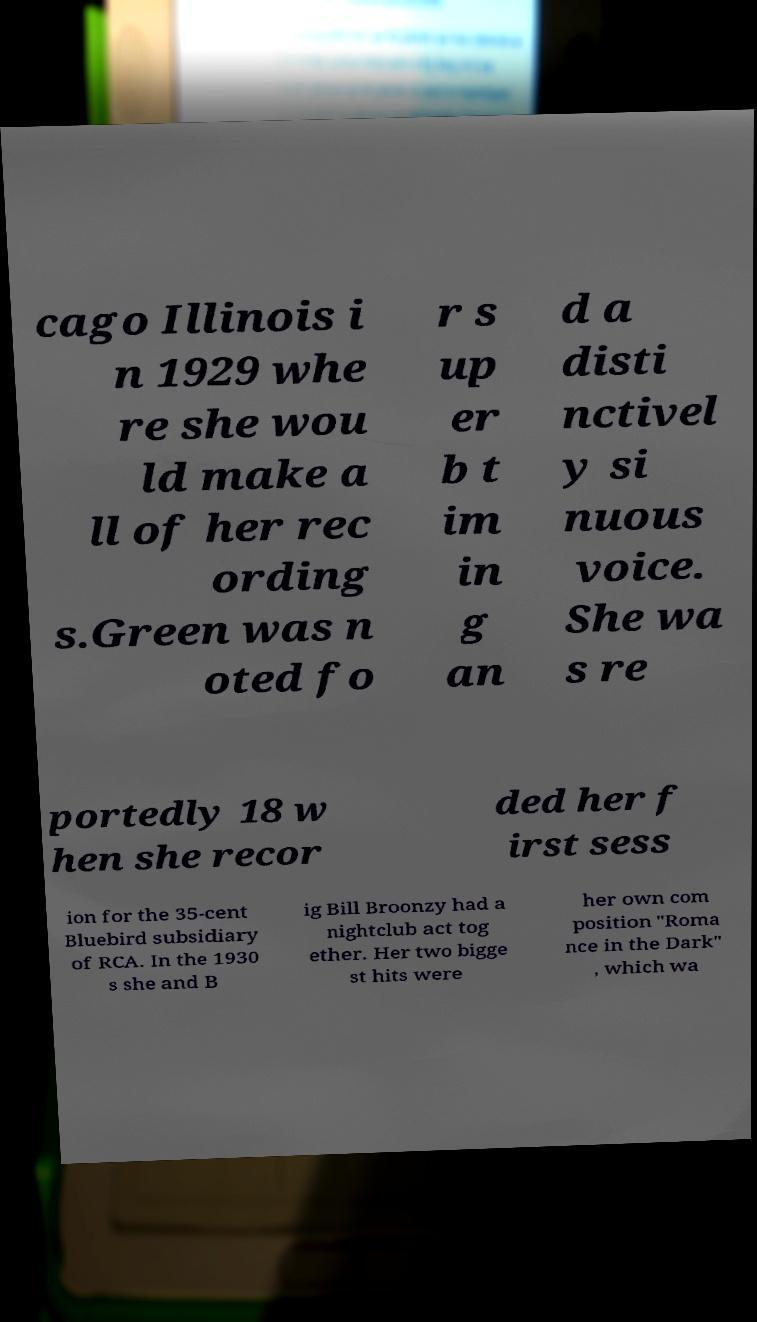Could you extract and type out the text from this image? cago Illinois i n 1929 whe re she wou ld make a ll of her rec ording s.Green was n oted fo r s up er b t im in g an d a disti nctivel y si nuous voice. She wa s re portedly 18 w hen she recor ded her f irst sess ion for the 35-cent Bluebird subsidiary of RCA. In the 1930 s she and B ig Bill Broonzy had a nightclub act tog ether. Her two bigge st hits were her own com position "Roma nce in the Dark" , which wa 